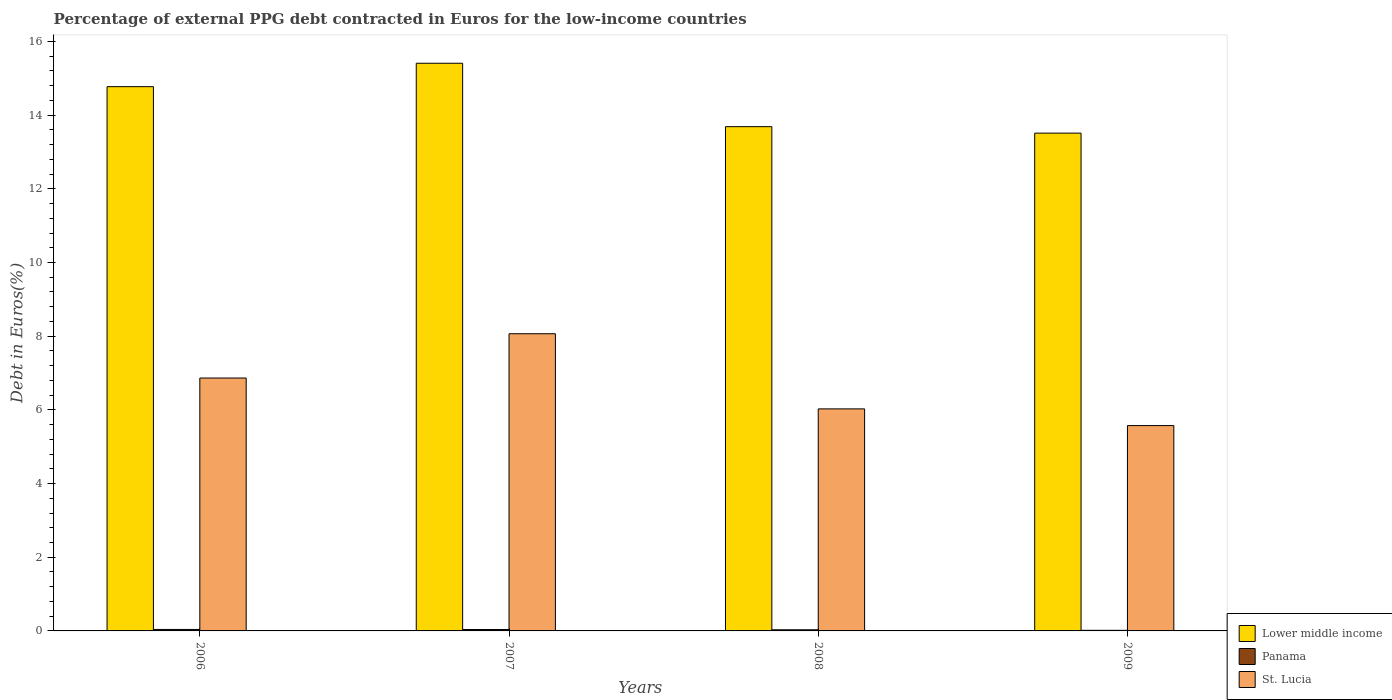Are the number of bars per tick equal to the number of legend labels?
Your answer should be very brief. Yes. How many bars are there on the 4th tick from the right?
Offer a very short reply. 3. What is the label of the 1st group of bars from the left?
Offer a very short reply. 2006. In how many cases, is the number of bars for a given year not equal to the number of legend labels?
Make the answer very short. 0. What is the percentage of external PPG debt contracted in Euros in Panama in 2008?
Your response must be concise. 0.03. Across all years, what is the maximum percentage of external PPG debt contracted in Euros in Lower middle income?
Your response must be concise. 15.41. Across all years, what is the minimum percentage of external PPG debt contracted in Euros in Lower middle income?
Keep it short and to the point. 13.51. What is the total percentage of external PPG debt contracted in Euros in St. Lucia in the graph?
Ensure brevity in your answer.  26.53. What is the difference between the percentage of external PPG debt contracted in Euros in St. Lucia in 2007 and that in 2008?
Make the answer very short. 2.04. What is the difference between the percentage of external PPG debt contracted in Euros in Panama in 2007 and the percentage of external PPG debt contracted in Euros in St. Lucia in 2009?
Give a very brief answer. -5.54. What is the average percentage of external PPG debt contracted in Euros in Lower middle income per year?
Provide a short and direct response. 14.34. In the year 2007, what is the difference between the percentage of external PPG debt contracted in Euros in Lower middle income and percentage of external PPG debt contracted in Euros in Panama?
Make the answer very short. 15.37. What is the ratio of the percentage of external PPG debt contracted in Euros in Lower middle income in 2006 to that in 2009?
Ensure brevity in your answer.  1.09. Is the difference between the percentage of external PPG debt contracted in Euros in Lower middle income in 2006 and 2008 greater than the difference between the percentage of external PPG debt contracted in Euros in Panama in 2006 and 2008?
Your response must be concise. Yes. What is the difference between the highest and the second highest percentage of external PPG debt contracted in Euros in Panama?
Make the answer very short. 0. What is the difference between the highest and the lowest percentage of external PPG debt contracted in Euros in St. Lucia?
Keep it short and to the point. 2.49. In how many years, is the percentage of external PPG debt contracted in Euros in Panama greater than the average percentage of external PPG debt contracted in Euros in Panama taken over all years?
Provide a short and direct response. 2. Is the sum of the percentage of external PPG debt contracted in Euros in Panama in 2006 and 2007 greater than the maximum percentage of external PPG debt contracted in Euros in St. Lucia across all years?
Offer a terse response. No. What does the 3rd bar from the left in 2009 represents?
Keep it short and to the point. St. Lucia. What does the 2nd bar from the right in 2008 represents?
Offer a very short reply. Panama. How many years are there in the graph?
Your answer should be compact. 4. What is the difference between two consecutive major ticks on the Y-axis?
Offer a terse response. 2. Does the graph contain any zero values?
Offer a terse response. No. Does the graph contain grids?
Provide a short and direct response. No. What is the title of the graph?
Provide a succinct answer. Percentage of external PPG debt contracted in Euros for the low-income countries. What is the label or title of the X-axis?
Your answer should be very brief. Years. What is the label or title of the Y-axis?
Provide a succinct answer. Debt in Euros(%). What is the Debt in Euros(%) of Lower middle income in 2006?
Offer a terse response. 14.77. What is the Debt in Euros(%) of Panama in 2006?
Ensure brevity in your answer.  0.04. What is the Debt in Euros(%) in St. Lucia in 2006?
Offer a terse response. 6.86. What is the Debt in Euros(%) in Lower middle income in 2007?
Provide a succinct answer. 15.41. What is the Debt in Euros(%) of Panama in 2007?
Ensure brevity in your answer.  0.04. What is the Debt in Euros(%) of St. Lucia in 2007?
Make the answer very short. 8.07. What is the Debt in Euros(%) of Lower middle income in 2008?
Provide a succinct answer. 13.69. What is the Debt in Euros(%) of Panama in 2008?
Ensure brevity in your answer.  0.03. What is the Debt in Euros(%) in St. Lucia in 2008?
Keep it short and to the point. 6.03. What is the Debt in Euros(%) in Lower middle income in 2009?
Your response must be concise. 13.51. What is the Debt in Euros(%) in Panama in 2009?
Provide a short and direct response. 0.02. What is the Debt in Euros(%) in St. Lucia in 2009?
Keep it short and to the point. 5.57. Across all years, what is the maximum Debt in Euros(%) in Lower middle income?
Provide a short and direct response. 15.41. Across all years, what is the maximum Debt in Euros(%) in Panama?
Offer a very short reply. 0.04. Across all years, what is the maximum Debt in Euros(%) of St. Lucia?
Your response must be concise. 8.07. Across all years, what is the minimum Debt in Euros(%) in Lower middle income?
Your response must be concise. 13.51. Across all years, what is the minimum Debt in Euros(%) in Panama?
Make the answer very short. 0.02. Across all years, what is the minimum Debt in Euros(%) of St. Lucia?
Ensure brevity in your answer.  5.57. What is the total Debt in Euros(%) of Lower middle income in the graph?
Give a very brief answer. 57.38. What is the total Debt in Euros(%) of Panama in the graph?
Make the answer very short. 0.13. What is the total Debt in Euros(%) in St. Lucia in the graph?
Keep it short and to the point. 26.53. What is the difference between the Debt in Euros(%) in Lower middle income in 2006 and that in 2007?
Provide a short and direct response. -0.64. What is the difference between the Debt in Euros(%) in Panama in 2006 and that in 2007?
Make the answer very short. 0. What is the difference between the Debt in Euros(%) in St. Lucia in 2006 and that in 2007?
Your answer should be very brief. -1.2. What is the difference between the Debt in Euros(%) of Lower middle income in 2006 and that in 2008?
Provide a succinct answer. 1.09. What is the difference between the Debt in Euros(%) of Panama in 2006 and that in 2008?
Provide a succinct answer. 0.01. What is the difference between the Debt in Euros(%) in St. Lucia in 2006 and that in 2008?
Keep it short and to the point. 0.84. What is the difference between the Debt in Euros(%) of Lower middle income in 2006 and that in 2009?
Ensure brevity in your answer.  1.26. What is the difference between the Debt in Euros(%) in Panama in 2006 and that in 2009?
Offer a terse response. 0.02. What is the difference between the Debt in Euros(%) in St. Lucia in 2006 and that in 2009?
Give a very brief answer. 1.29. What is the difference between the Debt in Euros(%) of Lower middle income in 2007 and that in 2008?
Provide a succinct answer. 1.72. What is the difference between the Debt in Euros(%) of Panama in 2007 and that in 2008?
Your answer should be compact. 0.01. What is the difference between the Debt in Euros(%) of St. Lucia in 2007 and that in 2008?
Your answer should be compact. 2.04. What is the difference between the Debt in Euros(%) in Lower middle income in 2007 and that in 2009?
Your answer should be very brief. 1.9. What is the difference between the Debt in Euros(%) in Panama in 2007 and that in 2009?
Give a very brief answer. 0.02. What is the difference between the Debt in Euros(%) of St. Lucia in 2007 and that in 2009?
Your answer should be very brief. 2.49. What is the difference between the Debt in Euros(%) of Lower middle income in 2008 and that in 2009?
Your answer should be very brief. 0.18. What is the difference between the Debt in Euros(%) of Panama in 2008 and that in 2009?
Give a very brief answer. 0.01. What is the difference between the Debt in Euros(%) of St. Lucia in 2008 and that in 2009?
Your response must be concise. 0.45. What is the difference between the Debt in Euros(%) of Lower middle income in 2006 and the Debt in Euros(%) of Panama in 2007?
Your answer should be very brief. 14.73. What is the difference between the Debt in Euros(%) of Lower middle income in 2006 and the Debt in Euros(%) of St. Lucia in 2007?
Keep it short and to the point. 6.71. What is the difference between the Debt in Euros(%) of Panama in 2006 and the Debt in Euros(%) of St. Lucia in 2007?
Your answer should be compact. -8.03. What is the difference between the Debt in Euros(%) in Lower middle income in 2006 and the Debt in Euros(%) in Panama in 2008?
Offer a terse response. 14.74. What is the difference between the Debt in Euros(%) in Lower middle income in 2006 and the Debt in Euros(%) in St. Lucia in 2008?
Ensure brevity in your answer.  8.75. What is the difference between the Debt in Euros(%) in Panama in 2006 and the Debt in Euros(%) in St. Lucia in 2008?
Your answer should be very brief. -5.99. What is the difference between the Debt in Euros(%) in Lower middle income in 2006 and the Debt in Euros(%) in Panama in 2009?
Keep it short and to the point. 14.76. What is the difference between the Debt in Euros(%) of Lower middle income in 2006 and the Debt in Euros(%) of St. Lucia in 2009?
Offer a very short reply. 9.2. What is the difference between the Debt in Euros(%) of Panama in 2006 and the Debt in Euros(%) of St. Lucia in 2009?
Give a very brief answer. -5.53. What is the difference between the Debt in Euros(%) of Lower middle income in 2007 and the Debt in Euros(%) of Panama in 2008?
Provide a succinct answer. 15.38. What is the difference between the Debt in Euros(%) in Lower middle income in 2007 and the Debt in Euros(%) in St. Lucia in 2008?
Your response must be concise. 9.38. What is the difference between the Debt in Euros(%) of Panama in 2007 and the Debt in Euros(%) of St. Lucia in 2008?
Provide a succinct answer. -5.99. What is the difference between the Debt in Euros(%) in Lower middle income in 2007 and the Debt in Euros(%) in Panama in 2009?
Your response must be concise. 15.39. What is the difference between the Debt in Euros(%) of Lower middle income in 2007 and the Debt in Euros(%) of St. Lucia in 2009?
Ensure brevity in your answer.  9.83. What is the difference between the Debt in Euros(%) in Panama in 2007 and the Debt in Euros(%) in St. Lucia in 2009?
Give a very brief answer. -5.54. What is the difference between the Debt in Euros(%) in Lower middle income in 2008 and the Debt in Euros(%) in Panama in 2009?
Offer a very short reply. 13.67. What is the difference between the Debt in Euros(%) of Lower middle income in 2008 and the Debt in Euros(%) of St. Lucia in 2009?
Offer a terse response. 8.11. What is the difference between the Debt in Euros(%) of Panama in 2008 and the Debt in Euros(%) of St. Lucia in 2009?
Provide a succinct answer. -5.54. What is the average Debt in Euros(%) of Lower middle income per year?
Provide a succinct answer. 14.34. What is the average Debt in Euros(%) in Panama per year?
Keep it short and to the point. 0.03. What is the average Debt in Euros(%) of St. Lucia per year?
Give a very brief answer. 6.63. In the year 2006, what is the difference between the Debt in Euros(%) of Lower middle income and Debt in Euros(%) of Panama?
Give a very brief answer. 14.73. In the year 2006, what is the difference between the Debt in Euros(%) in Lower middle income and Debt in Euros(%) in St. Lucia?
Your answer should be compact. 7.91. In the year 2006, what is the difference between the Debt in Euros(%) of Panama and Debt in Euros(%) of St. Lucia?
Your answer should be very brief. -6.82. In the year 2007, what is the difference between the Debt in Euros(%) in Lower middle income and Debt in Euros(%) in Panama?
Offer a terse response. 15.37. In the year 2007, what is the difference between the Debt in Euros(%) of Lower middle income and Debt in Euros(%) of St. Lucia?
Your answer should be compact. 7.34. In the year 2007, what is the difference between the Debt in Euros(%) in Panama and Debt in Euros(%) in St. Lucia?
Your response must be concise. -8.03. In the year 2008, what is the difference between the Debt in Euros(%) in Lower middle income and Debt in Euros(%) in Panama?
Make the answer very short. 13.66. In the year 2008, what is the difference between the Debt in Euros(%) in Lower middle income and Debt in Euros(%) in St. Lucia?
Provide a short and direct response. 7.66. In the year 2008, what is the difference between the Debt in Euros(%) in Panama and Debt in Euros(%) in St. Lucia?
Give a very brief answer. -6. In the year 2009, what is the difference between the Debt in Euros(%) of Lower middle income and Debt in Euros(%) of Panama?
Your answer should be compact. 13.5. In the year 2009, what is the difference between the Debt in Euros(%) in Lower middle income and Debt in Euros(%) in St. Lucia?
Offer a very short reply. 7.94. In the year 2009, what is the difference between the Debt in Euros(%) of Panama and Debt in Euros(%) of St. Lucia?
Ensure brevity in your answer.  -5.56. What is the ratio of the Debt in Euros(%) of Lower middle income in 2006 to that in 2007?
Provide a succinct answer. 0.96. What is the ratio of the Debt in Euros(%) of Panama in 2006 to that in 2007?
Your response must be concise. 1.05. What is the ratio of the Debt in Euros(%) of St. Lucia in 2006 to that in 2007?
Provide a succinct answer. 0.85. What is the ratio of the Debt in Euros(%) of Lower middle income in 2006 to that in 2008?
Give a very brief answer. 1.08. What is the ratio of the Debt in Euros(%) of Panama in 2006 to that in 2008?
Offer a terse response. 1.31. What is the ratio of the Debt in Euros(%) of St. Lucia in 2006 to that in 2008?
Offer a very short reply. 1.14. What is the ratio of the Debt in Euros(%) in Lower middle income in 2006 to that in 2009?
Provide a succinct answer. 1.09. What is the ratio of the Debt in Euros(%) in Panama in 2006 to that in 2009?
Offer a very short reply. 2.47. What is the ratio of the Debt in Euros(%) of St. Lucia in 2006 to that in 2009?
Make the answer very short. 1.23. What is the ratio of the Debt in Euros(%) of Lower middle income in 2007 to that in 2008?
Provide a short and direct response. 1.13. What is the ratio of the Debt in Euros(%) in Panama in 2007 to that in 2008?
Provide a succinct answer. 1.24. What is the ratio of the Debt in Euros(%) of St. Lucia in 2007 to that in 2008?
Provide a short and direct response. 1.34. What is the ratio of the Debt in Euros(%) in Lower middle income in 2007 to that in 2009?
Keep it short and to the point. 1.14. What is the ratio of the Debt in Euros(%) in Panama in 2007 to that in 2009?
Your answer should be very brief. 2.35. What is the ratio of the Debt in Euros(%) of St. Lucia in 2007 to that in 2009?
Offer a very short reply. 1.45. What is the ratio of the Debt in Euros(%) in Panama in 2008 to that in 2009?
Your answer should be compact. 1.89. What is the ratio of the Debt in Euros(%) of St. Lucia in 2008 to that in 2009?
Your response must be concise. 1.08. What is the difference between the highest and the second highest Debt in Euros(%) of Lower middle income?
Your response must be concise. 0.64. What is the difference between the highest and the second highest Debt in Euros(%) in Panama?
Ensure brevity in your answer.  0. What is the difference between the highest and the second highest Debt in Euros(%) of St. Lucia?
Provide a succinct answer. 1.2. What is the difference between the highest and the lowest Debt in Euros(%) in Lower middle income?
Offer a terse response. 1.9. What is the difference between the highest and the lowest Debt in Euros(%) of Panama?
Ensure brevity in your answer.  0.02. What is the difference between the highest and the lowest Debt in Euros(%) in St. Lucia?
Your answer should be compact. 2.49. 